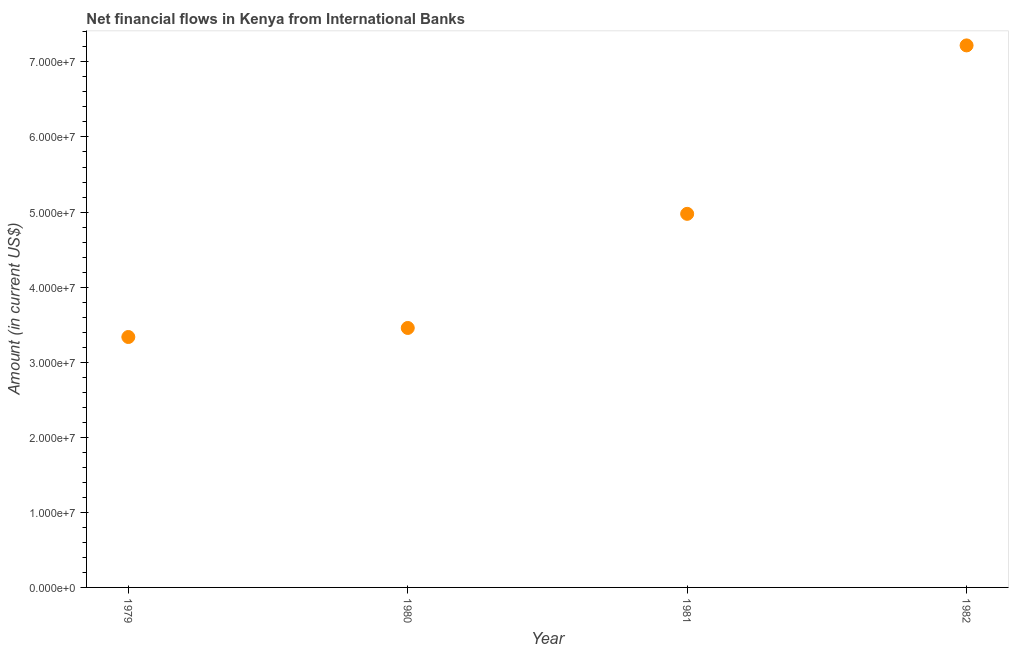What is the net financial flows from ibrd in 1980?
Your response must be concise. 3.46e+07. Across all years, what is the maximum net financial flows from ibrd?
Make the answer very short. 7.22e+07. Across all years, what is the minimum net financial flows from ibrd?
Your response must be concise. 3.34e+07. In which year was the net financial flows from ibrd maximum?
Your response must be concise. 1982. In which year was the net financial flows from ibrd minimum?
Provide a succinct answer. 1979. What is the sum of the net financial flows from ibrd?
Provide a short and direct response. 1.90e+08. What is the difference between the net financial flows from ibrd in 1980 and 1981?
Your answer should be compact. -1.52e+07. What is the average net financial flows from ibrd per year?
Your response must be concise. 4.75e+07. What is the median net financial flows from ibrd?
Offer a terse response. 4.22e+07. Do a majority of the years between 1982 and 1981 (inclusive) have net financial flows from ibrd greater than 46000000 US$?
Ensure brevity in your answer.  No. What is the ratio of the net financial flows from ibrd in 1979 to that in 1981?
Offer a terse response. 0.67. Is the net financial flows from ibrd in 1979 less than that in 1982?
Ensure brevity in your answer.  Yes. Is the difference between the net financial flows from ibrd in 1979 and 1980 greater than the difference between any two years?
Your response must be concise. No. What is the difference between the highest and the second highest net financial flows from ibrd?
Provide a succinct answer. 2.24e+07. Is the sum of the net financial flows from ibrd in 1979 and 1980 greater than the maximum net financial flows from ibrd across all years?
Offer a terse response. No. What is the difference between the highest and the lowest net financial flows from ibrd?
Make the answer very short. 3.88e+07. How many dotlines are there?
Offer a very short reply. 1. Are the values on the major ticks of Y-axis written in scientific E-notation?
Your answer should be very brief. Yes. Does the graph contain grids?
Your response must be concise. No. What is the title of the graph?
Your response must be concise. Net financial flows in Kenya from International Banks. What is the label or title of the X-axis?
Ensure brevity in your answer.  Year. What is the label or title of the Y-axis?
Give a very brief answer. Amount (in current US$). What is the Amount (in current US$) in 1979?
Your answer should be compact. 3.34e+07. What is the Amount (in current US$) in 1980?
Your answer should be very brief. 3.46e+07. What is the Amount (in current US$) in 1981?
Provide a short and direct response. 4.98e+07. What is the Amount (in current US$) in 1982?
Provide a succinct answer. 7.22e+07. What is the difference between the Amount (in current US$) in 1979 and 1980?
Keep it short and to the point. -1.20e+06. What is the difference between the Amount (in current US$) in 1979 and 1981?
Make the answer very short. -1.64e+07. What is the difference between the Amount (in current US$) in 1979 and 1982?
Your answer should be compact. -3.88e+07. What is the difference between the Amount (in current US$) in 1980 and 1981?
Offer a very short reply. -1.52e+07. What is the difference between the Amount (in current US$) in 1980 and 1982?
Your answer should be very brief. -3.76e+07. What is the difference between the Amount (in current US$) in 1981 and 1982?
Provide a succinct answer. -2.24e+07. What is the ratio of the Amount (in current US$) in 1979 to that in 1980?
Offer a very short reply. 0.96. What is the ratio of the Amount (in current US$) in 1979 to that in 1981?
Provide a short and direct response. 0.67. What is the ratio of the Amount (in current US$) in 1979 to that in 1982?
Give a very brief answer. 0.46. What is the ratio of the Amount (in current US$) in 1980 to that in 1981?
Provide a succinct answer. 0.69. What is the ratio of the Amount (in current US$) in 1980 to that in 1982?
Offer a terse response. 0.48. What is the ratio of the Amount (in current US$) in 1981 to that in 1982?
Give a very brief answer. 0.69. 